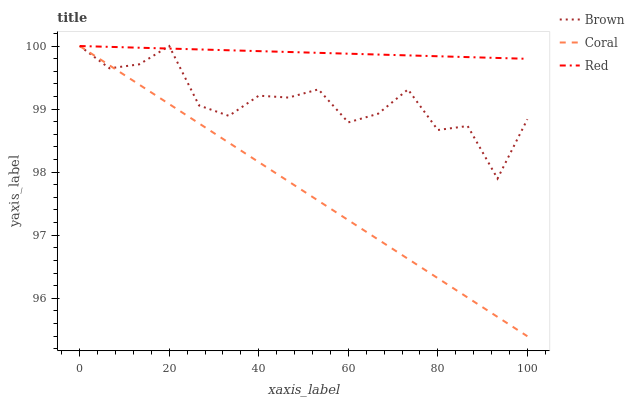Does Coral have the minimum area under the curve?
Answer yes or no. Yes. Does Red have the maximum area under the curve?
Answer yes or no. Yes. Does Red have the minimum area under the curve?
Answer yes or no. No. Does Coral have the maximum area under the curve?
Answer yes or no. No. Is Red the smoothest?
Answer yes or no. Yes. Is Brown the roughest?
Answer yes or no. Yes. Is Coral the smoothest?
Answer yes or no. No. Is Coral the roughest?
Answer yes or no. No. Does Coral have the lowest value?
Answer yes or no. Yes. Does Red have the lowest value?
Answer yes or no. No. Does Red have the highest value?
Answer yes or no. Yes. Does Brown intersect Coral?
Answer yes or no. Yes. Is Brown less than Coral?
Answer yes or no. No. Is Brown greater than Coral?
Answer yes or no. No. 